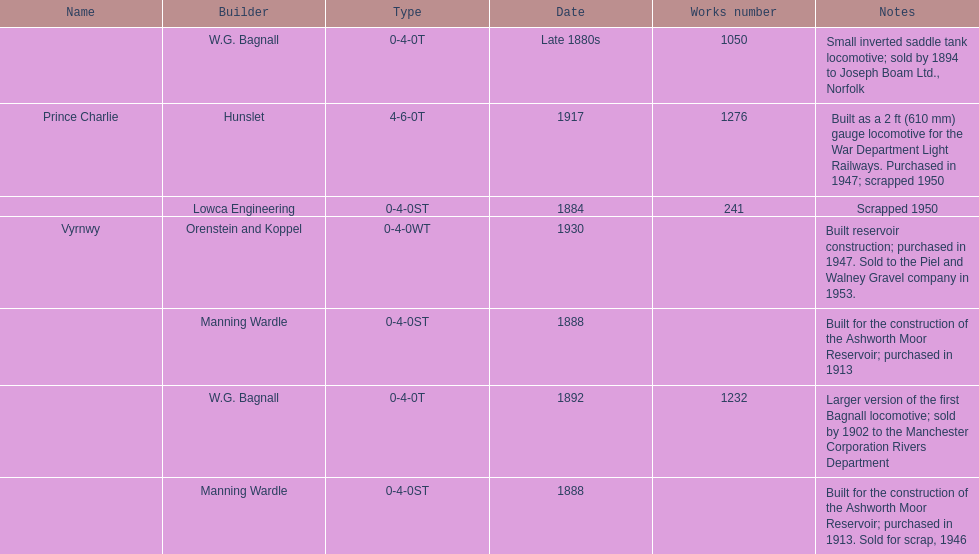How many locomotives were scrapped? 3. 